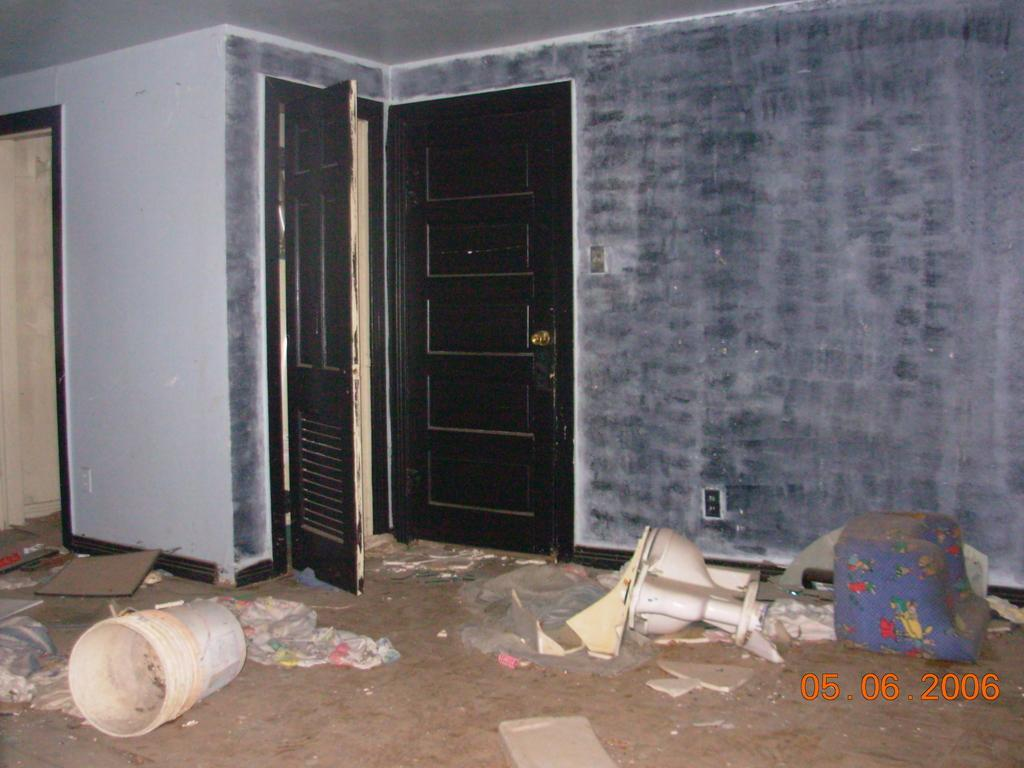What is the perspective of the image? The image is taken from inside. What can be seen in the image? There is a bucket and a toilet seat in the image. How would you describe the appearance of the surface in the image? The surface looks messy due to the many objects present. What can be seen in the background of the image? There is a wall and doors in the background of the image. Can you see the legs of the guide in the image? There is no guide or legs visible in the image. What book is the person reading in the image? There is no person or book present in the image. 